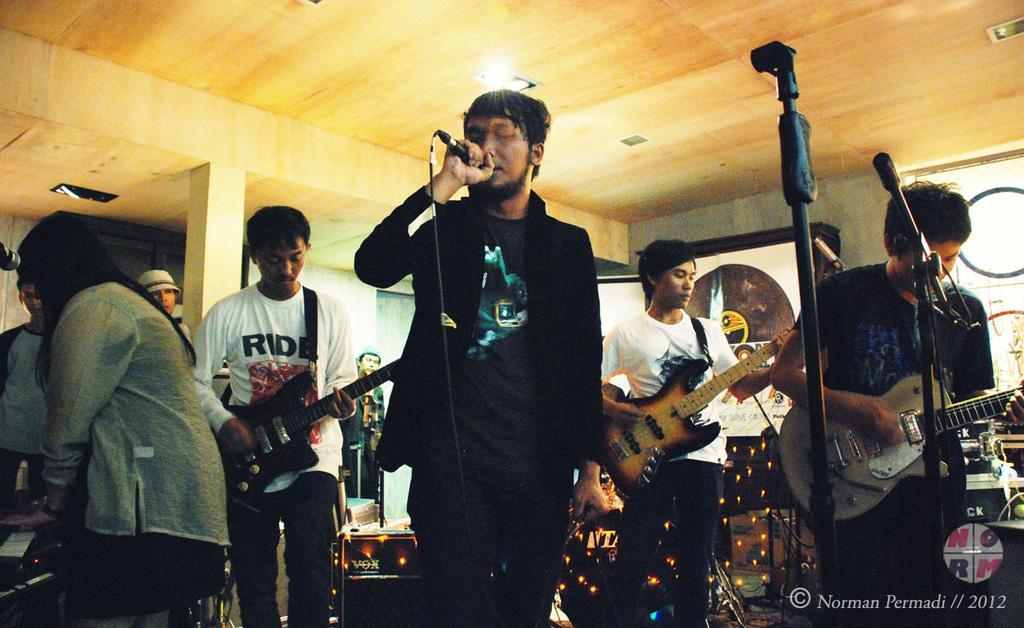Could you give a brief overview of what you see in this image? In this picture we can see group of people playing a guitar in the microphone, a person from left wearing white t- shirt is playing brown guitar and a person in center wearing black jacket and t-shirt is singing on the microphone. And a woman sitting on chair and playing piano in the left corner. 